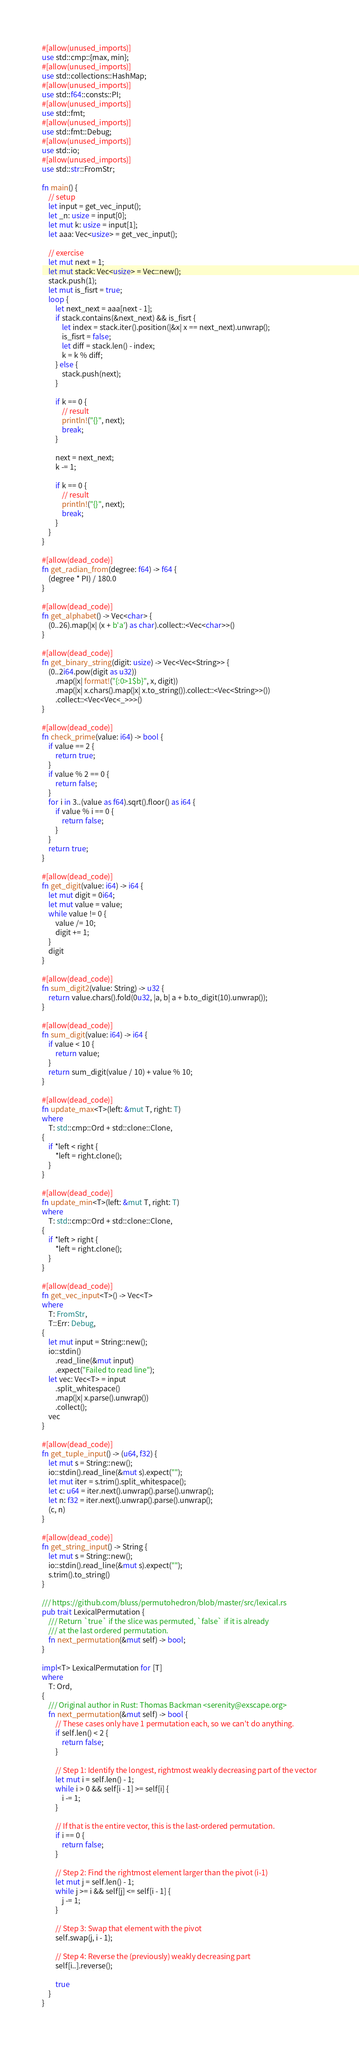<code> <loc_0><loc_0><loc_500><loc_500><_Rust_>#[allow(unused_imports)]
use std::cmp::{max, min};
#[allow(unused_imports)]
use std::collections::HashMap;
#[allow(unused_imports)]
use std::f64::consts::PI;
#[allow(unused_imports)]
use std::fmt;
#[allow(unused_imports)]
use std::fmt::Debug;
#[allow(unused_imports)]
use std::io;
#[allow(unused_imports)]
use std::str::FromStr;

fn main() {
    // setup
    let input = get_vec_input();
    let _n: usize = input[0];
    let mut k: usize = input[1];
    let aaa: Vec<usize> = get_vec_input();

    // exercise
    let mut next = 1;
    let mut stack: Vec<usize> = Vec::new();
    stack.push(1);
    let mut is_fisrt = true;
    loop {
        let next_next = aaa[next - 1];
        if stack.contains(&next_next) && is_fisrt {
            let index = stack.iter().position(|&x| x == next_next).unwrap();
            is_fisrt = false;
            let diff = stack.len() - index;
            k = k % diff;
        } else {
            stack.push(next);
        }

        if k == 0 {
            // result
            println!("{}", next);
            break;
        }

        next = next_next;
        k -= 1;

        if k == 0 {
            // result
            println!("{}", next);
            break;
        }
    }
}

#[allow(dead_code)]
fn get_radian_from(degree: f64) -> f64 {
    (degree * PI) / 180.0
}

#[allow(dead_code)]
fn get_alphabet() -> Vec<char> {
    (0..26).map(|x| (x + b'a') as char).collect::<Vec<char>>()
}

#[allow(dead_code)]
fn get_binary_string(digit: usize) -> Vec<Vec<String>> {
    (0..2i64.pow(digit as u32))
        .map(|x| format!("{:0>1$b}", x, digit))
        .map(|x| x.chars().map(|x| x.to_string()).collect::<Vec<String>>())
        .collect::<Vec<Vec<_>>>()
}

#[allow(dead_code)]
fn check_prime(value: i64) -> bool {
    if value == 2 {
        return true;
    }
    if value % 2 == 0 {
        return false;
    }
    for i in 3..(value as f64).sqrt().floor() as i64 {
        if value % i == 0 {
            return false;
        }
    }
    return true;
}

#[allow(dead_code)]
fn get_digit(value: i64) -> i64 {
    let mut digit = 0i64;
    let mut value = value;
    while value != 0 {
        value /= 10;
        digit += 1;
    }
    digit
}

#[allow(dead_code)]
fn sum_digit2(value: String) -> u32 {
    return value.chars().fold(0u32, |a, b| a + b.to_digit(10).unwrap());
}

#[allow(dead_code)]
fn sum_digit(value: i64) -> i64 {
    if value < 10 {
        return value;
    }
    return sum_digit(value / 10) + value % 10;
}

#[allow(dead_code)]
fn update_max<T>(left: &mut T, right: T)
where
    T: std::cmp::Ord + std::clone::Clone,
{
    if *left < right {
        *left = right.clone();
    }
}

#[allow(dead_code)]
fn update_min<T>(left: &mut T, right: T)
where
    T: std::cmp::Ord + std::clone::Clone,
{
    if *left > right {
        *left = right.clone();
    }
}

#[allow(dead_code)]
fn get_vec_input<T>() -> Vec<T>
where
    T: FromStr,
    T::Err: Debug,
{
    let mut input = String::new();
    io::stdin()
        .read_line(&mut input)
        .expect("Failed to read line");
    let vec: Vec<T> = input
        .split_whitespace()
        .map(|x| x.parse().unwrap())
        .collect();
    vec
}

#[allow(dead_code)]
fn get_tuple_input() -> (u64, f32) {
    let mut s = String::new();
    io::stdin().read_line(&mut s).expect("");
    let mut iter = s.trim().split_whitespace();
    let c: u64 = iter.next().unwrap().parse().unwrap();
    let n: f32 = iter.next().unwrap().parse().unwrap();
    (c, n)
}

#[allow(dead_code)]
fn get_string_input() -> String {
    let mut s = String::new();
    io::stdin().read_line(&mut s).expect("");
    s.trim().to_string()
}

/// https://github.com/bluss/permutohedron/blob/master/src/lexical.rs
pub trait LexicalPermutation {
    /// Return `true` if the slice was permuted, `false` if it is already
    /// at the last ordered permutation.
    fn next_permutation(&mut self) -> bool;
}

impl<T> LexicalPermutation for [T]
where
    T: Ord,
{
    /// Original author in Rust: Thomas Backman <serenity@exscape.org>
    fn next_permutation(&mut self) -> bool {
        // These cases only have 1 permutation each, so we can't do anything.
        if self.len() < 2 {
            return false;
        }

        // Step 1: Identify the longest, rightmost weakly decreasing part of the vector
        let mut i = self.len() - 1;
        while i > 0 && self[i - 1] >= self[i] {
            i -= 1;
        }

        // If that is the entire vector, this is the last-ordered permutation.
        if i == 0 {
            return false;
        }

        // Step 2: Find the rightmost element larger than the pivot (i-1)
        let mut j = self.len() - 1;
        while j >= i && self[j] <= self[i - 1] {
            j -= 1;
        }

        // Step 3: Swap that element with the pivot
        self.swap(j, i - 1);

        // Step 4: Reverse the (previously) weakly decreasing part
        self[i..].reverse();

        true
    }
}
</code> 